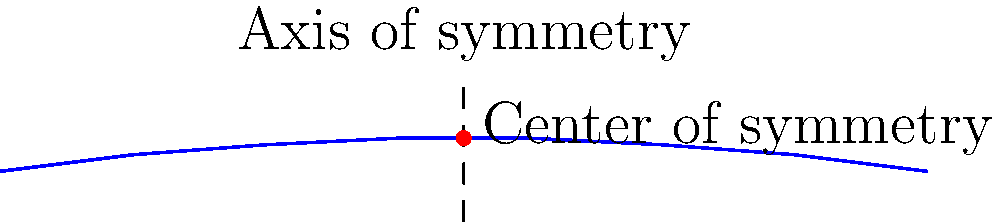Consider the simplified wing design shown in the diagram. Which symmetry group best describes the wing's shape, and how would this impact the aerodynamic properties of the aircraft? To determine the symmetry group of the wing design and its impact on aerodynamic properties, let's analyze the diagram step-by-step:

1. Reflection symmetry: The wing appears to be symmetrical about a vertical axis through its center. This suggests the presence of a reflection symmetry.

2. Rotational symmetry: The wing does not exhibit rotational symmetry of any order greater than 1 (i.e., 360° rotation).

3. Translation symmetry: There is no translation symmetry in this finite wing design.

4. Symmetry group identification: The combination of reflection symmetry and 360° rotational symmetry (order 1) corresponds to the Dihedral group of order 2, denoted as $D_1$ or $C_{2v}$.

5. Aerodynamic implications:
   a) Lift generation: The symmetrical design ensures equal pressure distribution on both sides of the wing when at zero angle of attack.
   b) Stability: The reflection symmetry contributes to lateral stability during flight.
   c) Drag reduction: Symmetrical airfoils typically have lower drag at zero lift conditions.
   d) Versatility: This design allows for consistent performance in both normal and inverted flight.

6. Limitations: While symmetrical designs offer certain advantages, they may not provide optimal lift-to-drag ratios for all flight conditions, potentially requiring higher angles of attack for lift generation compared to cambered airfoils.

In aircraft design, understanding these symmetry properties is crucial for predicting and optimizing aerodynamic performance across various flight regimes.
Answer: $D_1$ (or $C_{2v}$) symmetry group; balanced lift, enhanced stability, lower drag at zero lift, versatile performance. 